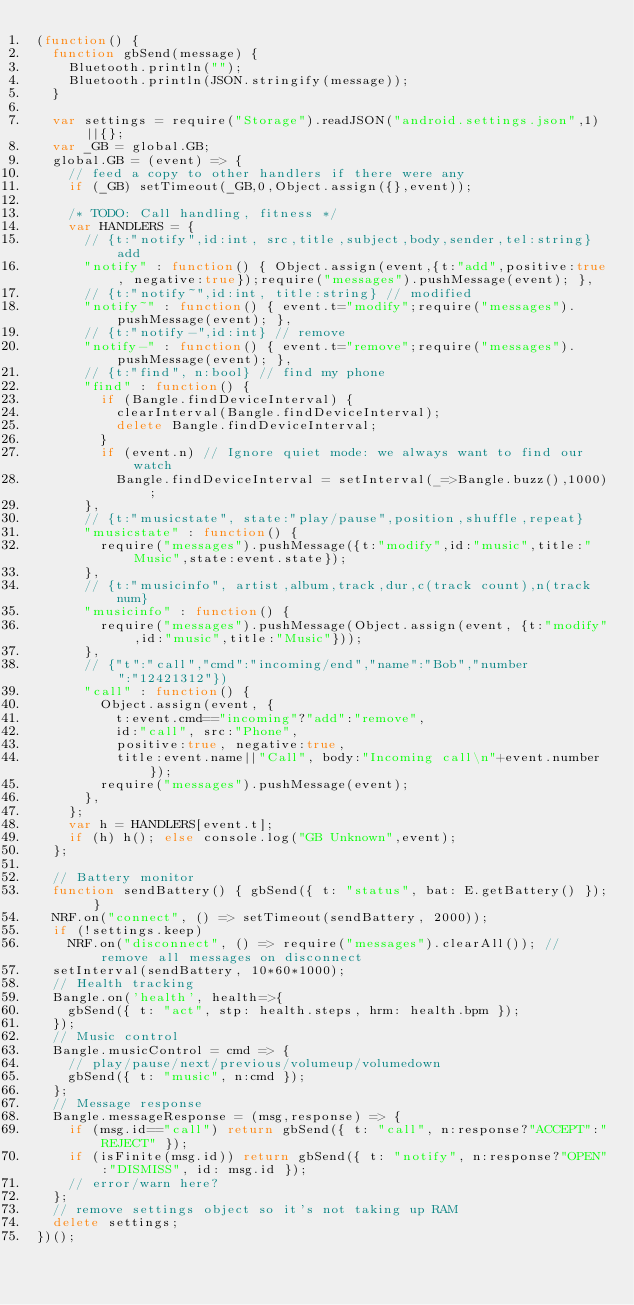Convert code to text. <code><loc_0><loc_0><loc_500><loc_500><_JavaScript_>(function() {
  function gbSend(message) {
    Bluetooth.println("");
    Bluetooth.println(JSON.stringify(message));
  }

  var settings = require("Storage").readJSON("android.settings.json",1)||{};
  var _GB = global.GB;
  global.GB = (event) => {
    // feed a copy to other handlers if there were any
    if (_GB) setTimeout(_GB,0,Object.assign({},event));

    /* TODO: Call handling, fitness */
    var HANDLERS = {
      // {t:"notify",id:int, src,title,subject,body,sender,tel:string} add
      "notify" : function() { Object.assign(event,{t:"add",positive:true, negative:true});require("messages").pushMessage(event); },
      // {t:"notify~",id:int, title:string} // modified
      "notify~" : function() { event.t="modify";require("messages").pushMessage(event); },
      // {t:"notify-",id:int} // remove
      "notify-" : function() { event.t="remove";require("messages").pushMessage(event); },
      // {t:"find", n:bool} // find my phone
      "find" : function() {
        if (Bangle.findDeviceInterval) {
          clearInterval(Bangle.findDeviceInterval);
          delete Bangle.findDeviceInterval;
        }
        if (event.n) // Ignore quiet mode: we always want to find our watch
          Bangle.findDeviceInterval = setInterval(_=>Bangle.buzz(),1000);
      },
      // {t:"musicstate", state:"play/pause",position,shuffle,repeat}
      "musicstate" : function() {
        require("messages").pushMessage({t:"modify",id:"music",title:"Music",state:event.state});
      },
      // {t:"musicinfo", artist,album,track,dur,c(track count),n(track num}
      "musicinfo" : function() {
        require("messages").pushMessage(Object.assign(event, {t:"modify",id:"music",title:"Music"}));
      },
      // {"t":"call","cmd":"incoming/end","name":"Bob","number":"12421312"})
      "call" : function() {
        Object.assign(event, {
          t:event.cmd=="incoming"?"add":"remove",
          id:"call", src:"Phone",
          positive:true, negative:true,
          title:event.name||"Call", body:"Incoming call\n"+event.number});
        require("messages").pushMessage(event);
      },
    };
    var h = HANDLERS[event.t];
    if (h) h(); else console.log("GB Unknown",event);
  };

  // Battery monitor
  function sendBattery() { gbSend({ t: "status", bat: E.getBattery() }); }
  NRF.on("connect", () => setTimeout(sendBattery, 2000));
  if (!settings.keep)
    NRF.on("disconnect", () => require("messages").clearAll()); // remove all messages on disconnect
  setInterval(sendBattery, 10*60*1000);
  // Health tracking
  Bangle.on('health', health=>{
    gbSend({ t: "act", stp: health.steps, hrm: health.bpm });
  });
  // Music control
  Bangle.musicControl = cmd => {
    // play/pause/next/previous/volumeup/volumedown
    gbSend({ t: "music", n:cmd });
  };
  // Message response
  Bangle.messageResponse = (msg,response) => {
    if (msg.id=="call") return gbSend({ t: "call", n:response?"ACCEPT":"REJECT" });
    if (isFinite(msg.id)) return gbSend({ t: "notify", n:response?"OPEN":"DISMISS", id: msg.id });
    // error/warn here?
  };
  // remove settings object so it's not taking up RAM
  delete settings;
})();
</code> 